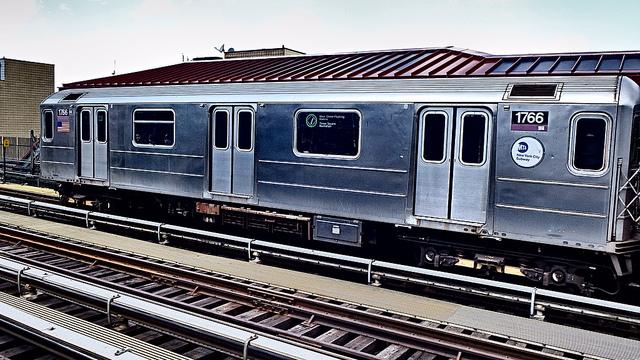Is the train on the tracks in the foreground?
Answer briefly. No. What vehicle is this?
Short answer required. Train. How many doors are visible on the train?
Concise answer only. 6. 